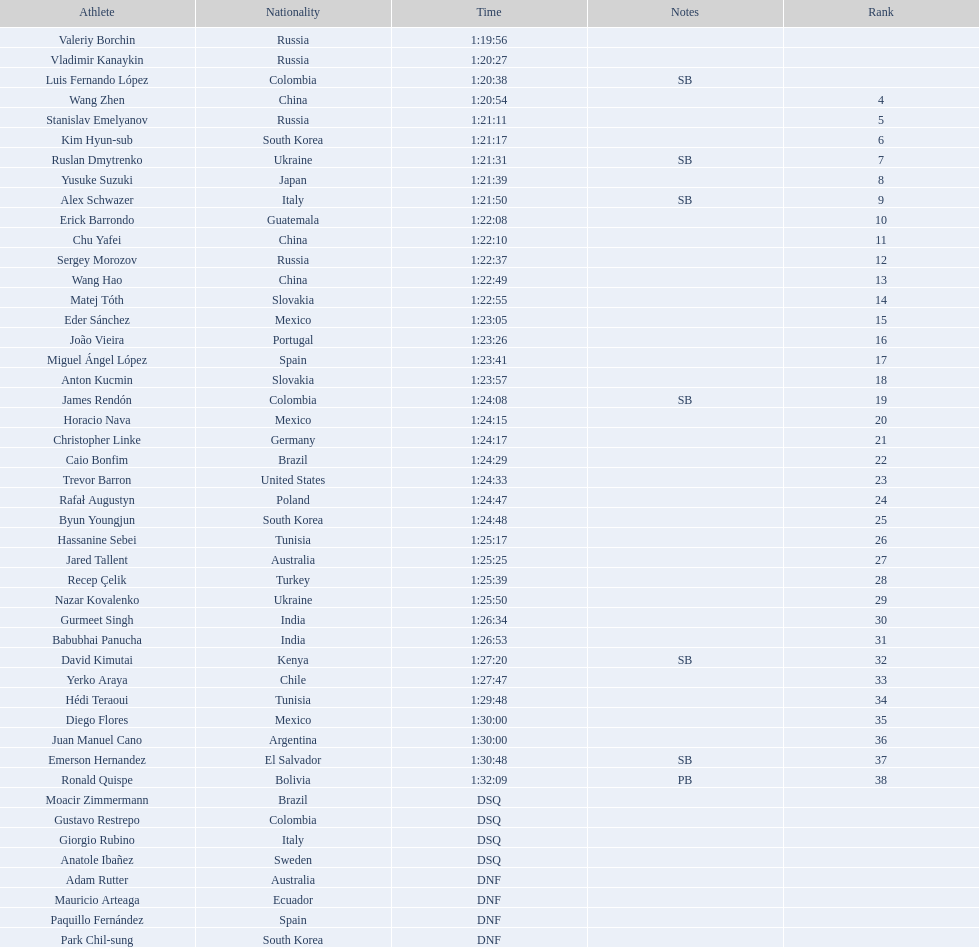Which competitor was ranked first? Valeriy Borchin. 